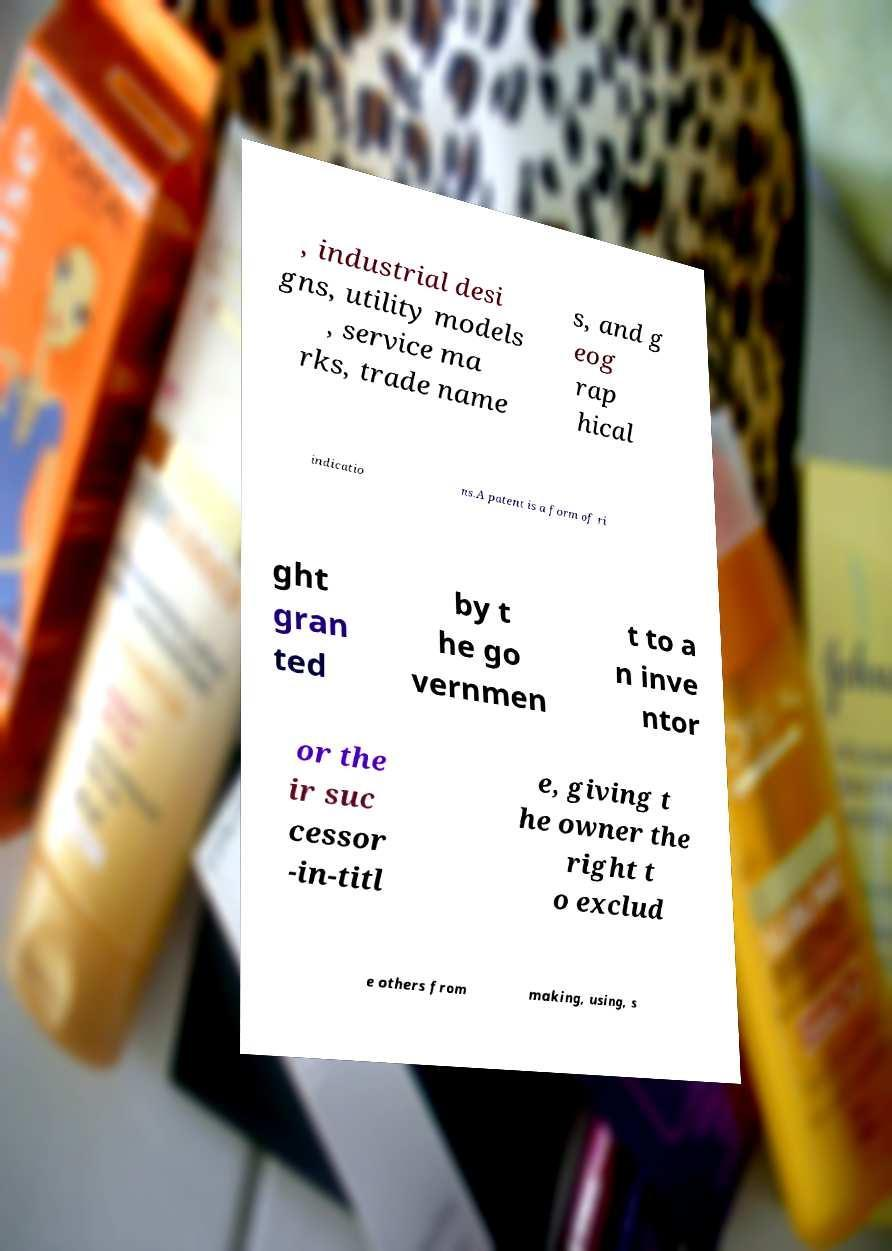Can you accurately transcribe the text from the provided image for me? , industrial desi gns, utility models , service ma rks, trade name s, and g eog rap hical indicatio ns.A patent is a form of ri ght gran ted by t he go vernmen t to a n inve ntor or the ir suc cessor -in-titl e, giving t he owner the right t o exclud e others from making, using, s 